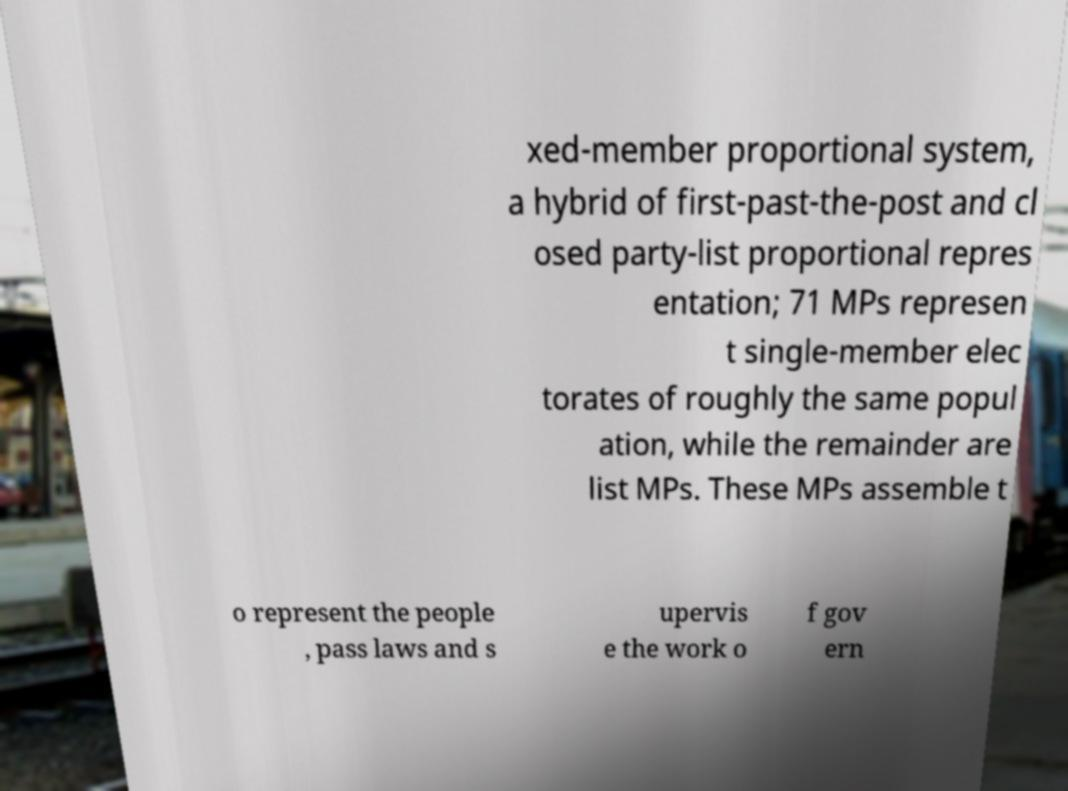Can you read and provide the text displayed in the image?This photo seems to have some interesting text. Can you extract and type it out for me? xed-member proportional system, a hybrid of first-past-the-post and cl osed party-list proportional repres entation; 71 MPs represen t single-member elec torates of roughly the same popul ation, while the remainder are list MPs. These MPs assemble t o represent the people , pass laws and s upervis e the work o f gov ern 